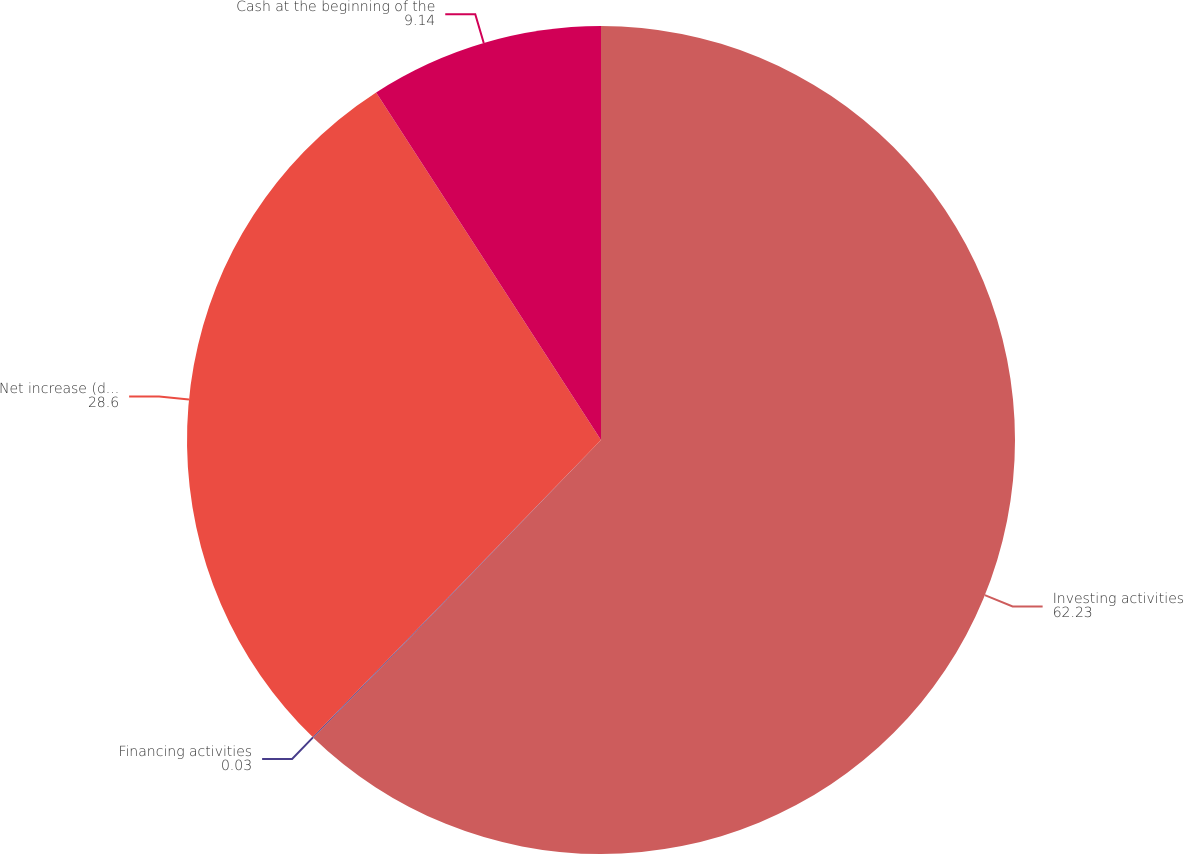<chart> <loc_0><loc_0><loc_500><loc_500><pie_chart><fcel>Investing activities<fcel>Financing activities<fcel>Net increase (decrease) in<fcel>Cash at the beginning of the<nl><fcel>62.23%<fcel>0.03%<fcel>28.6%<fcel>9.14%<nl></chart> 